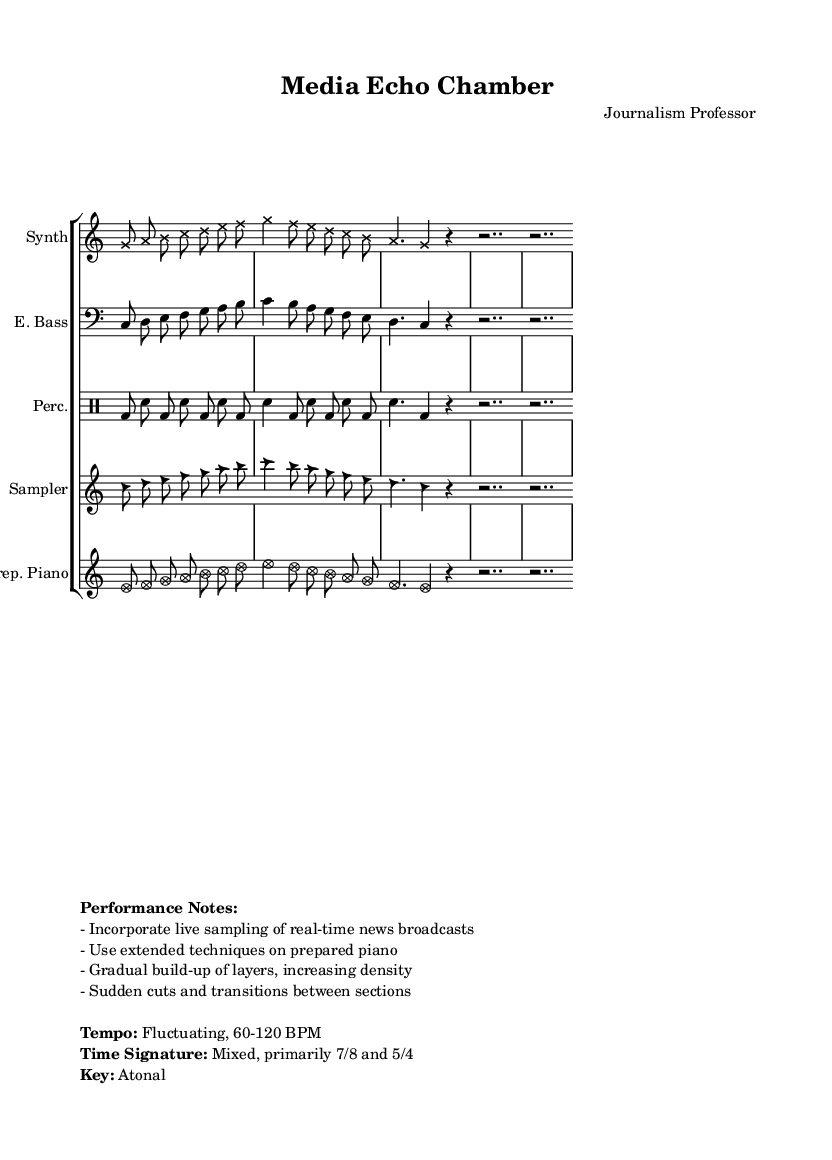What is the time signature of this piece? The time signature of the piece is indicated as 7/8, which means there are seven eighth notes per measure. This is clearly stated in the global settings of the sheet music.
Answer: 7/8 What is the tempo indicated for the piece? The tempo is described as fluctuating between 60-120 BPM. This is noted under the performance instructions in the markup section of the sheet music.
Answer: Fluctuating, 60-120 BPM What instrument is designated as "Perc." in the score? The instrument labeled "Perc." refers to percussion, which is identified in the score structure where a separate drum staff is created for it.
Answer: Percussion What is the key signature of this composition? The key signature is noted as atonal, which indicates that the piece does not adhere to a specific tonal center or scale. This information is also found in the performance notes section.
Answer: Atonal How many parts are included in the staff group? The staff group includes five distinct parts: Synth, Electric Bass, Percussion, Sampler, and Prepared Piano. This can be counted from the score layout, where each staff represents an instrument part.
Answer: 5 What unique techniques are suggested for the prepared piano? The score notes the use of extended techniques on the prepared piano, which implies unusual playing methods to create distinct sound effects. This is explicitly stated in the performance notes section.
Answer: Extended techniques How many times is the repetition indicated in this piece? The repetition is explicitly indicated to occur twice in each instrumental part, as stated by the "repeat unfold 2" instruction in the individual parts. This instruction can be seen throughout the individual score sections.
Answer: 2 